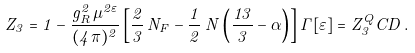Convert formula to latex. <formula><loc_0><loc_0><loc_500><loc_500>Z _ { 3 } = 1 - \frac { g _ { R } ^ { 2 } \, \mu ^ { 2 \varepsilon } } { ( 4 \pi ) ^ { 2 } } \left [ \frac { 2 } { 3 } \, N _ { F } - \frac { 1 } { 2 } \, N \left ( \frac { 1 3 } { 3 } - \alpha \right ) \right ] \Gamma [ \varepsilon ] = Z _ { 3 } ^ { Q } C D \, .</formula> 